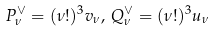<formula> <loc_0><loc_0><loc_500><loc_500>P _ { \nu } ^ { \vee } = ( \nu ! ) ^ { 3 } { v _ { \nu } } , \, Q _ { \nu } ^ { \vee } = ( \nu ! ) ^ { 3 } { u _ { \nu } }</formula> 